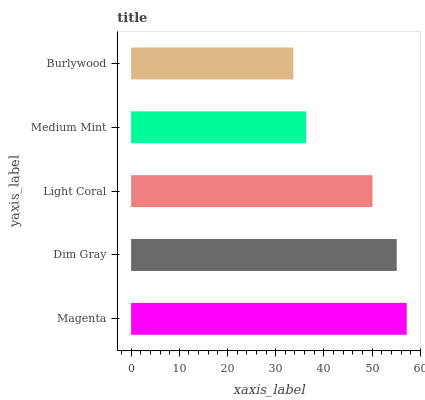Is Burlywood the minimum?
Answer yes or no. Yes. Is Magenta the maximum?
Answer yes or no. Yes. Is Dim Gray the minimum?
Answer yes or no. No. Is Dim Gray the maximum?
Answer yes or no. No. Is Magenta greater than Dim Gray?
Answer yes or no. Yes. Is Dim Gray less than Magenta?
Answer yes or no. Yes. Is Dim Gray greater than Magenta?
Answer yes or no. No. Is Magenta less than Dim Gray?
Answer yes or no. No. Is Light Coral the high median?
Answer yes or no. Yes. Is Light Coral the low median?
Answer yes or no. Yes. Is Medium Mint the high median?
Answer yes or no. No. Is Dim Gray the low median?
Answer yes or no. No. 